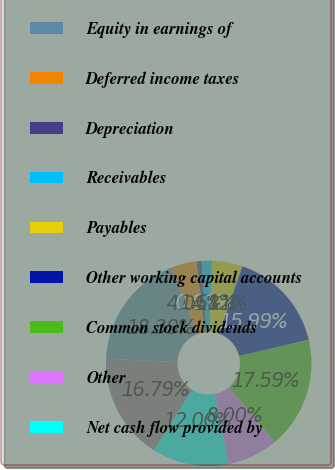Convert chart to OTSL. <chart><loc_0><loc_0><loc_500><loc_500><pie_chart><fcel>Net income<fcel>Equity in earnings of<fcel>Deferred income taxes<fcel>Depreciation<fcel>Receivables<fcel>Payables<fcel>Other working capital accounts<fcel>Common stock dividends<fcel>Other<fcel>Net cash flow provided by<nl><fcel>16.79%<fcel>18.39%<fcel>4.01%<fcel>0.81%<fcel>1.61%<fcel>4.81%<fcel>15.99%<fcel>17.59%<fcel>8.0%<fcel>12.0%<nl></chart> 